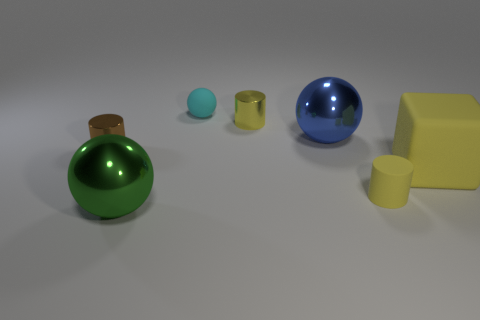The yellow block that is behind the ball that is in front of the shiny ball behind the yellow matte cube is made of what material?
Give a very brief answer. Rubber. What number of matte objects are the same size as the cyan matte ball?
Ensure brevity in your answer.  1. What is the material of the sphere that is both in front of the small cyan rubber ball and behind the matte block?
Your answer should be very brief. Metal. How many small yellow cylinders are behind the big blue object?
Give a very brief answer. 1. Does the brown object have the same shape as the large metallic object that is to the right of the big green shiny object?
Your response must be concise. No. Is there a big yellow thing that has the same shape as the big blue metallic thing?
Keep it short and to the point. No. What shape is the rubber thing behind the large metallic object behind the green sphere?
Give a very brief answer. Sphere. What is the shape of the shiny thing in front of the big cube?
Ensure brevity in your answer.  Sphere. Do the large shiny object on the left side of the tiny rubber sphere and the cylinder that is to the left of the green thing have the same color?
Ensure brevity in your answer.  No. What number of big spheres are both in front of the big yellow thing and right of the big green metal sphere?
Offer a very short reply. 0. 